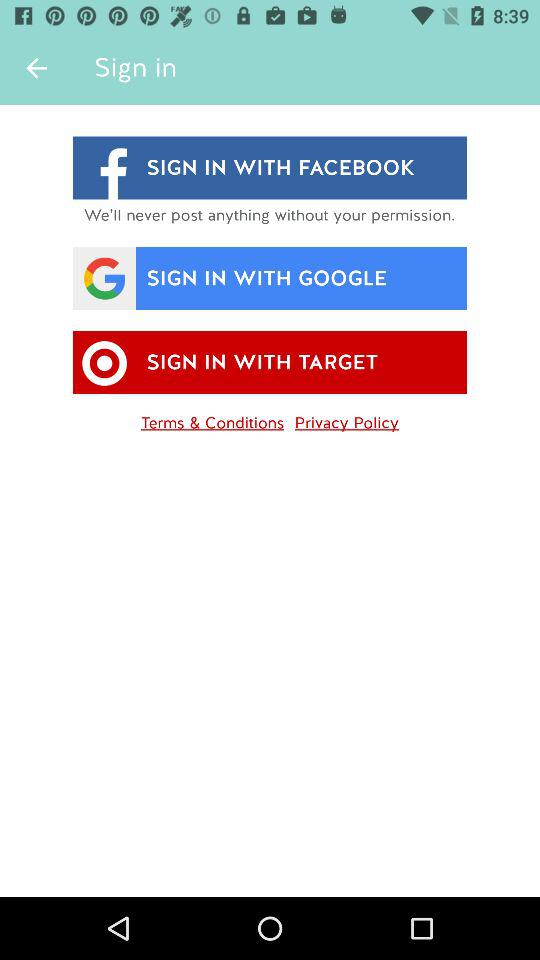How many sign in options are there?
Answer the question using a single word or phrase. 3 